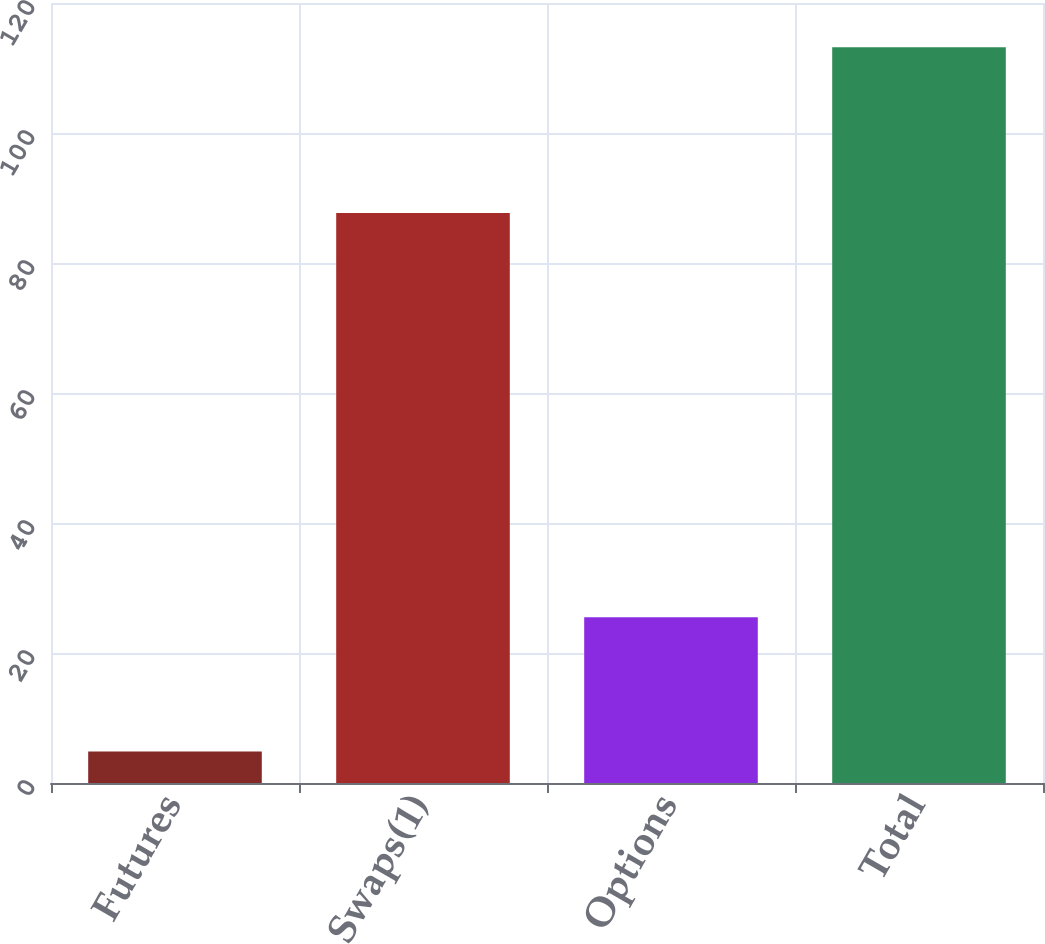Convert chart. <chart><loc_0><loc_0><loc_500><loc_500><bar_chart><fcel>Futures<fcel>Swaps(1)<fcel>Options<fcel>Total<nl><fcel>4.83<fcel>87.7<fcel>25.5<fcel>113.2<nl></chart> 